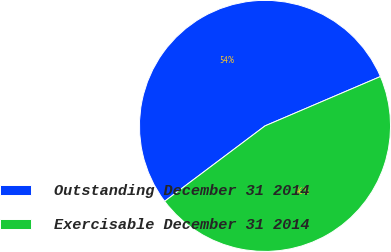Convert chart to OTSL. <chart><loc_0><loc_0><loc_500><loc_500><pie_chart><fcel>Outstanding December 31 2014<fcel>Exercisable December 31 2014<nl><fcel>53.82%<fcel>46.18%<nl></chart> 